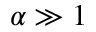Convert formula to latex. <formula><loc_0><loc_0><loc_500><loc_500>\alpha \gg 1</formula> 